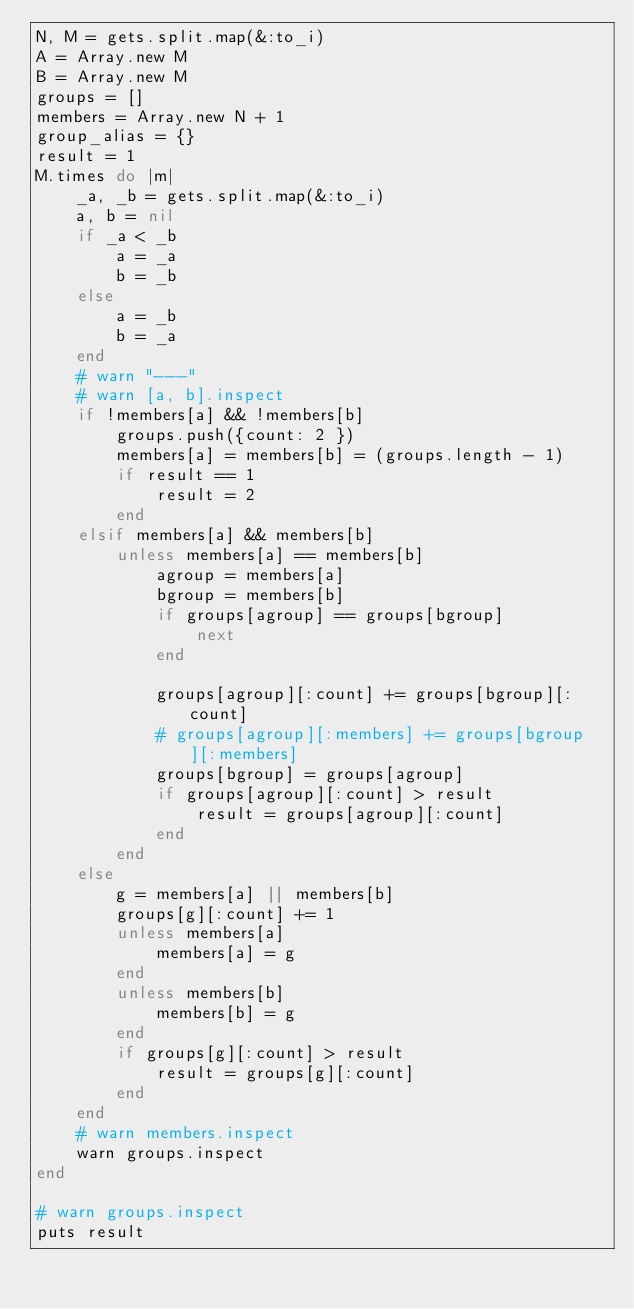<code> <loc_0><loc_0><loc_500><loc_500><_Ruby_>N, M = gets.split.map(&:to_i)
A = Array.new M
B = Array.new M
groups = []
members = Array.new N + 1
group_alias = {}
result = 1
M.times do |m|
    _a, _b = gets.split.map(&:to_i)
    a, b = nil
    if _a < _b
        a = _a
        b = _b
    else
        a = _b
        b = _a
    end
    # warn "---"
    # warn [a, b].inspect
    if !members[a] && !members[b]
        groups.push({count: 2 })
        members[a] = members[b] = (groups.length - 1)
        if result == 1
            result = 2
        end
    elsif members[a] && members[b]
        unless members[a] == members[b]
            agroup = members[a]
            bgroup = members[b]
            if groups[agroup] == groups[bgroup]
                next
            end

            groups[agroup][:count] += groups[bgroup][:count]
            # groups[agroup][:members] += groups[bgroup][:members]
            groups[bgroup] = groups[agroup]
            if groups[agroup][:count] > result
                result = groups[agroup][:count]
            end
        end
    else
        g = members[a] || members[b]
        groups[g][:count] += 1
        unless members[a]
            members[a] = g
        end
        unless members[b]
            members[b] = g
        end
        if groups[g][:count] > result
            result = groups[g][:count]
        end
    end
    # warn members.inspect
    warn groups.inspect
end

# warn groups.inspect
puts result</code> 